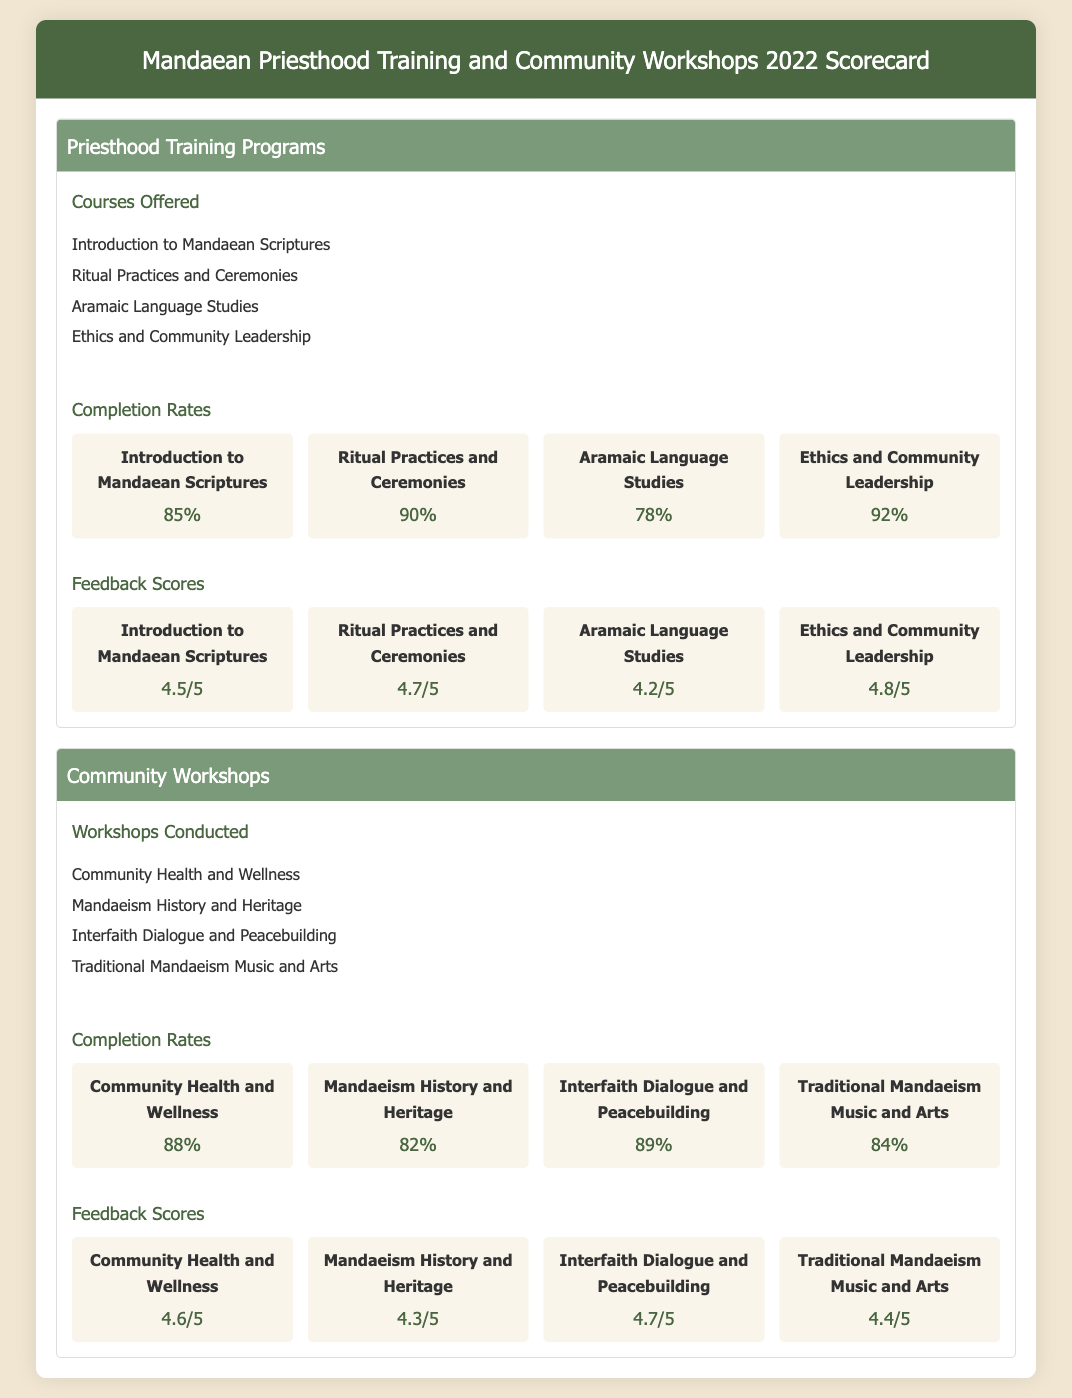What are the courses offered in Priesthood Training Programs? The document lists four courses under Priesthood Training Programs, which include "Introduction to Mandaean Scriptures," "Ritual Practices and Ceremonies," "Aramaic Language Studies," and "Ethics and Community Leadership."
Answer: Introduction to Mandaean Scriptures, Ritual Practices and Ceremonies, Aramaic Language Studies, Ethics and Community Leadership What was the completion rate for Ethics and Community Leadership? The completion rate is directly cited in the document for each course, indicating a specific percentage, which for Ethics and Community Leadership is 92%.
Answer: 92% What feedback score did the "Interfaith Dialogue and Peacebuilding" workshop receive? The feedback scores for all workshops are provided, showing that "Interfaith Dialogue and Peacebuilding" received a score of 4.7 out of 5.
Answer: 4.7/5 Which course had the lowest completion rate? By comparing the completion rates listed, we can see that "Aramaic Language Studies" had the lowest completion rate at 78%.
Answer: 78% What is the overall theme of the document? The primary purpose and content of the document focus on assessing educational programs and outcomes for Priesthood Training and Community Workshops.
Answer: Educational programs and outcomes 